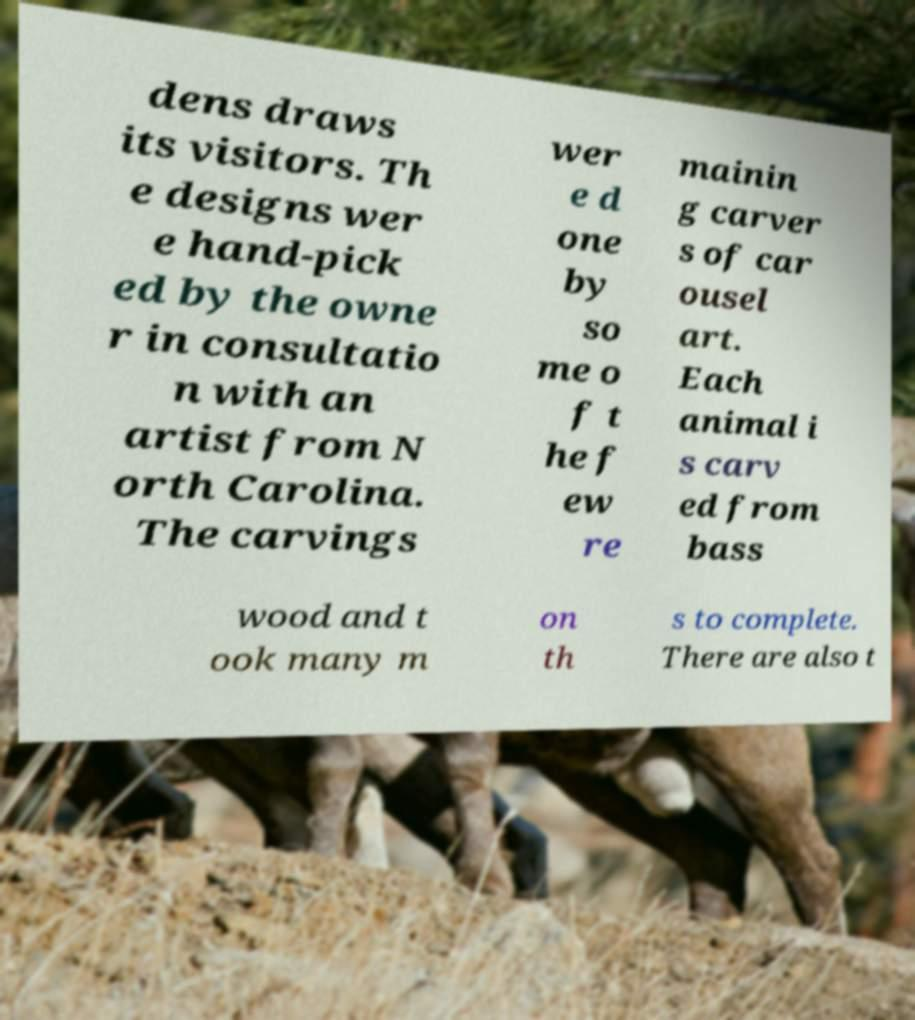There's text embedded in this image that I need extracted. Can you transcribe it verbatim? dens draws its visitors. Th e designs wer e hand-pick ed by the owne r in consultatio n with an artist from N orth Carolina. The carvings wer e d one by so me o f t he f ew re mainin g carver s of car ousel art. Each animal i s carv ed from bass wood and t ook many m on th s to complete. There are also t 